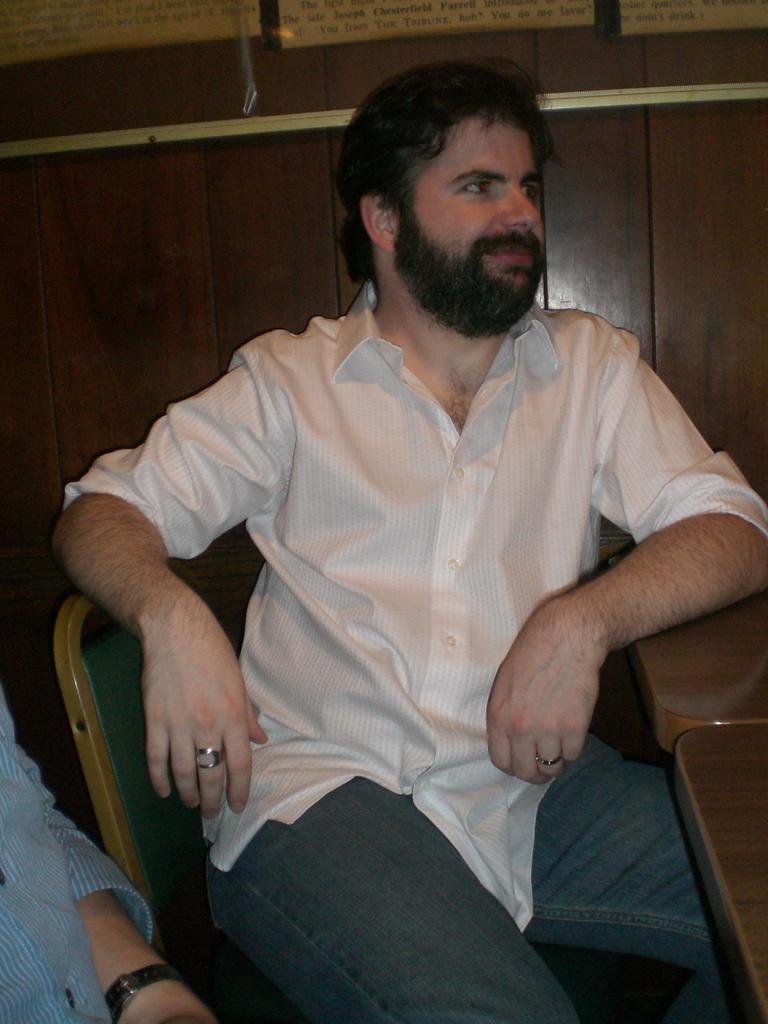Please provide a concise description of this image. There is a man wearing white shirt is sitting on the chair. he has full beard on his face and he is smiling slightly. In the background there is a wooden wall. 